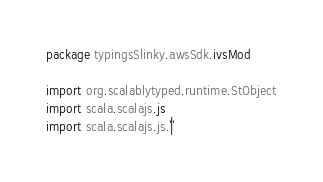<code> <loc_0><loc_0><loc_500><loc_500><_Scala_>package typingsSlinky.awsSdk.ivsMod

import org.scalablytyped.runtime.StObject
import scala.scalajs.js
import scala.scalajs.js.`|`</code> 